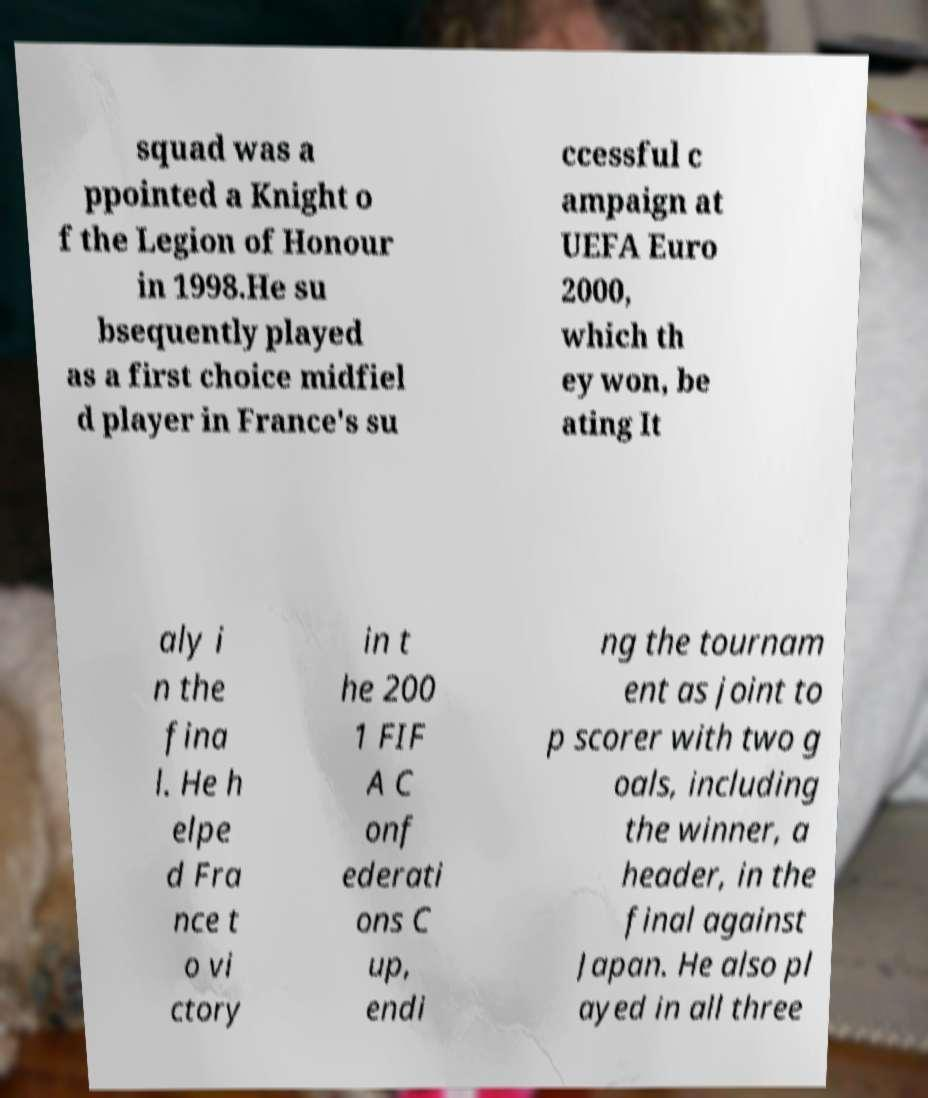There's text embedded in this image that I need extracted. Can you transcribe it verbatim? squad was a ppointed a Knight o f the Legion of Honour in 1998.He su bsequently played as a first choice midfiel d player in France's su ccessful c ampaign at UEFA Euro 2000, which th ey won, be ating It aly i n the fina l. He h elpe d Fra nce t o vi ctory in t he 200 1 FIF A C onf ederati ons C up, endi ng the tournam ent as joint to p scorer with two g oals, including the winner, a header, in the final against Japan. He also pl ayed in all three 